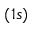<formula> <loc_0><loc_0><loc_500><loc_500>( 1 s )</formula> 